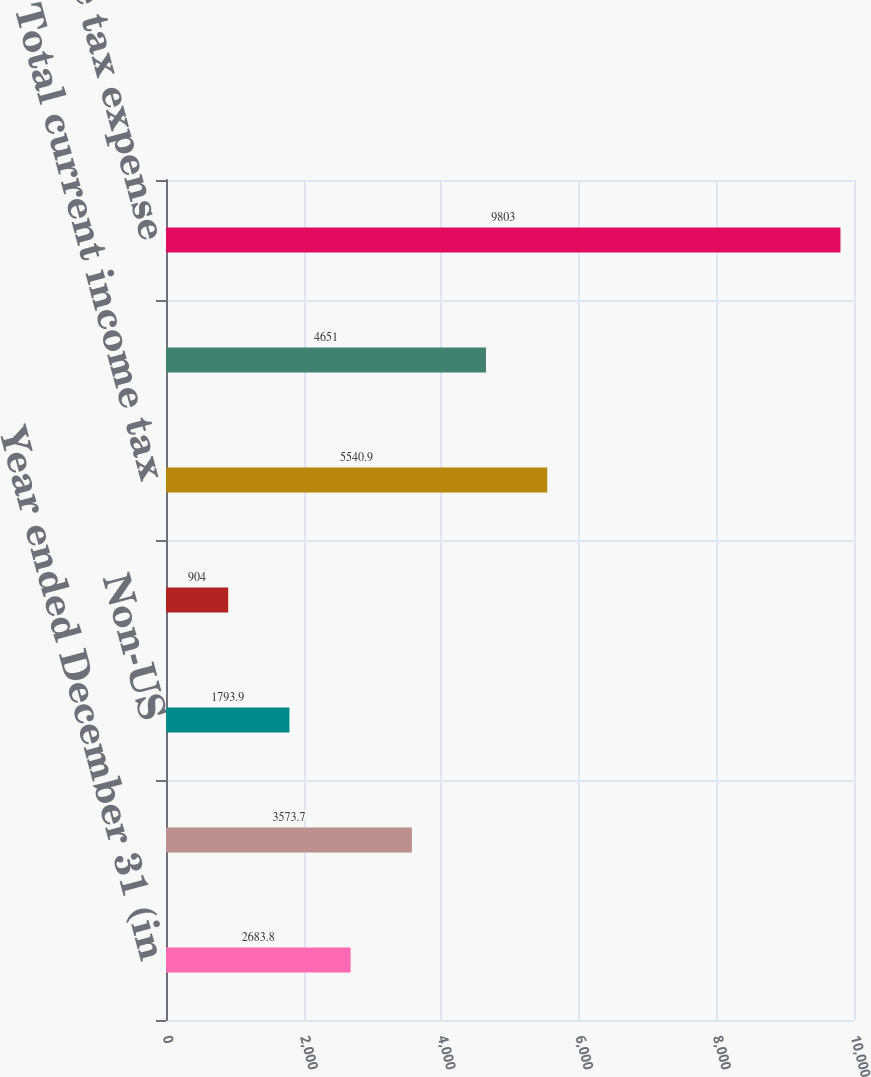Convert chart to OTSL. <chart><loc_0><loc_0><loc_500><loc_500><bar_chart><fcel>Year ended December 31 (in<fcel>US federal<fcel>Non-US<fcel>US state and local<fcel>Total current income tax<fcel>Total deferred income tax<fcel>Total income tax expense<nl><fcel>2683.8<fcel>3573.7<fcel>1793.9<fcel>904<fcel>5540.9<fcel>4651<fcel>9803<nl></chart> 